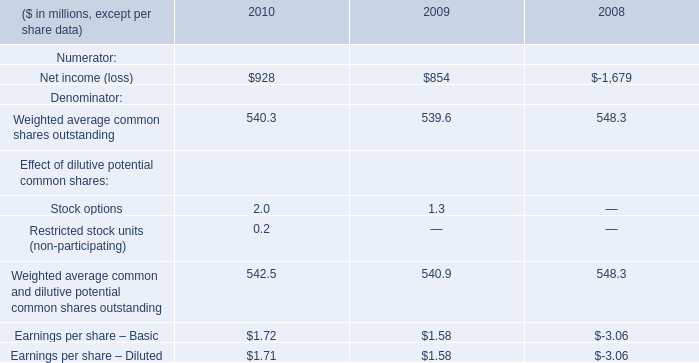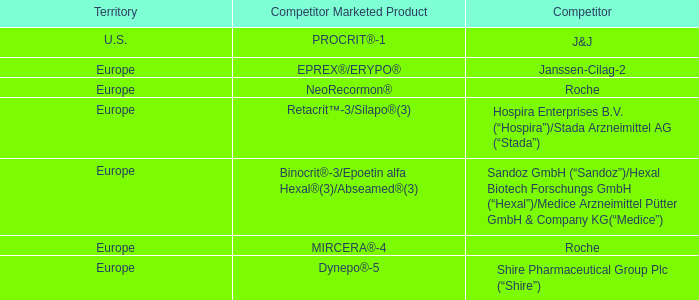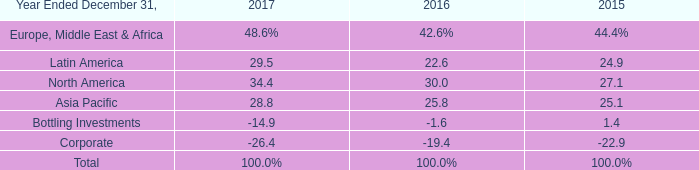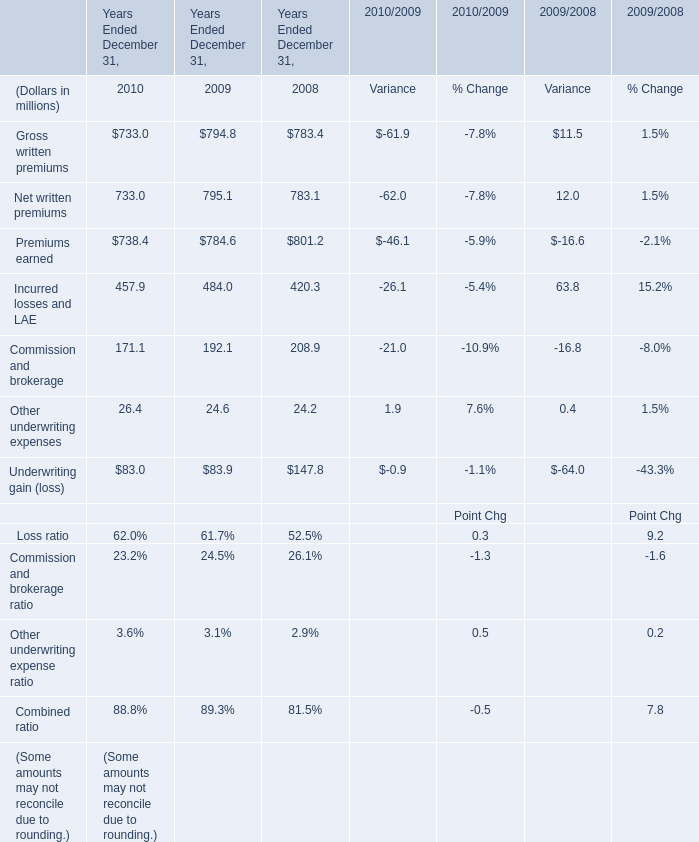In the year with lowest amount of Commission and brokerage, what's the increasing rate of Other underwriting expenses? 
Computations: ((26.4 - 24.6) / 24.6)
Answer: 0.07317. 